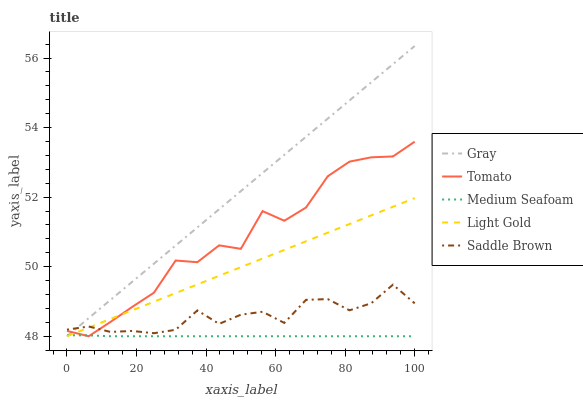Does Light Gold have the minimum area under the curve?
Answer yes or no. No. Does Light Gold have the maximum area under the curve?
Answer yes or no. No. Is Light Gold the smoothest?
Answer yes or no. No. Is Light Gold the roughest?
Answer yes or no. No. Does Saddle Brown have the lowest value?
Answer yes or no. No. Does Light Gold have the highest value?
Answer yes or no. No. Is Medium Seafoam less than Saddle Brown?
Answer yes or no. Yes. Is Saddle Brown greater than Medium Seafoam?
Answer yes or no. Yes. Does Medium Seafoam intersect Saddle Brown?
Answer yes or no. No. 